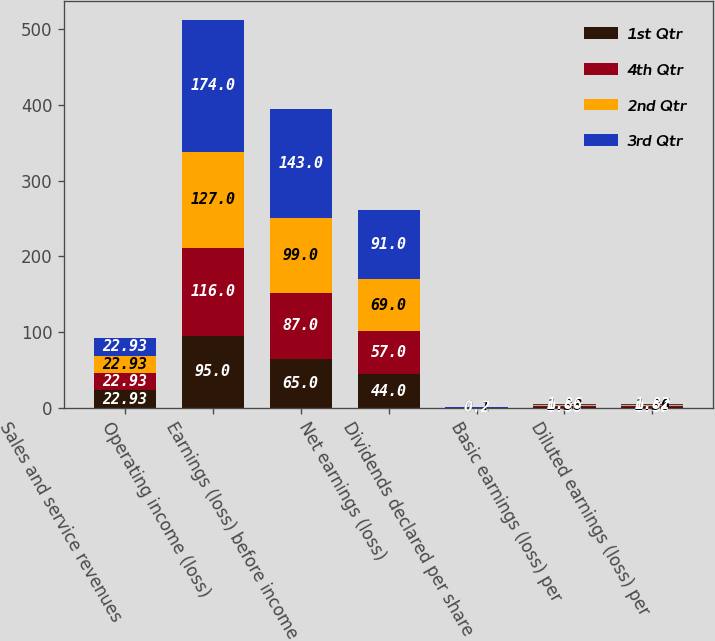Convert chart to OTSL. <chart><loc_0><loc_0><loc_500><loc_500><stacked_bar_chart><ecel><fcel>Sales and service revenues<fcel>Operating income (loss)<fcel>Earnings (loss) before income<fcel>Net earnings (loss)<fcel>Dividends declared per share<fcel>Basic earnings (loss) per<fcel>Diluted earnings (loss) per<nl><fcel>1st Qtr<fcel>22.93<fcel>95<fcel>65<fcel>44<fcel>0.1<fcel>0.88<fcel>0.87<nl><fcel>4th Qtr<fcel>22.93<fcel>116<fcel>87<fcel>57<fcel>0.1<fcel>1.14<fcel>1.12<nl><fcel>2nd Qtr<fcel>22.93<fcel>127<fcel>99<fcel>69<fcel>0.1<fcel>1.38<fcel>1.36<nl><fcel>3rd Qtr<fcel>22.93<fcel>174<fcel>143<fcel>91<fcel>0.2<fcel>1.86<fcel>1.82<nl></chart> 